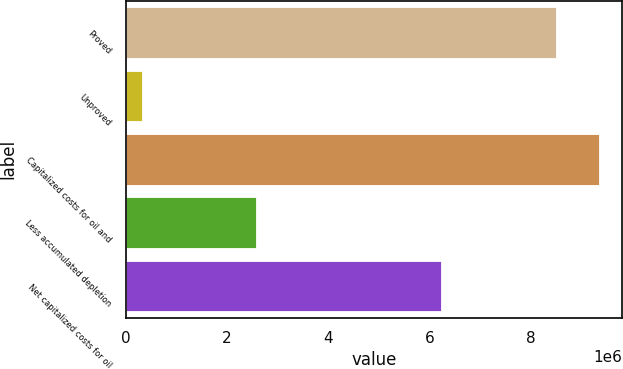Convert chart to OTSL. <chart><loc_0><loc_0><loc_500><loc_500><bar_chart><fcel>Proved<fcel>Unproved<fcel>Capitalized costs for oil and<fcel>Less accumulated depletion<fcel>Net capitalized costs for oil<nl><fcel>8.49925e+06<fcel>313881<fcel>9.34918e+06<fcel>2.57795e+06<fcel>6.23519e+06<nl></chart> 